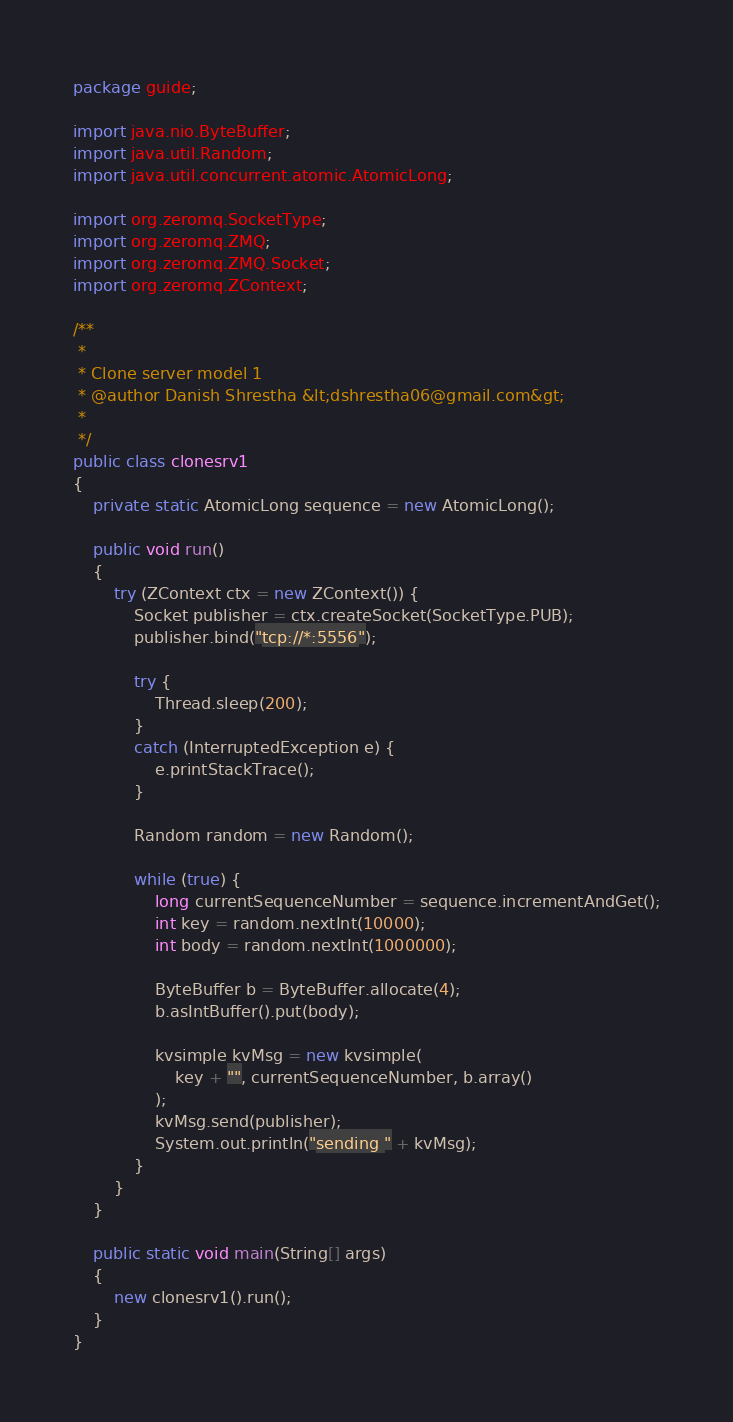Convert code to text. <code><loc_0><loc_0><loc_500><loc_500><_Java_>package guide;

import java.nio.ByteBuffer;
import java.util.Random;
import java.util.concurrent.atomic.AtomicLong;

import org.zeromq.SocketType;
import org.zeromq.ZMQ;
import org.zeromq.ZMQ.Socket;
import org.zeromq.ZContext;

/**
 * 
 * Clone server model 1
 * @author Danish Shrestha &lt;dshrestha06@gmail.com&gt;
 *
 */
public class clonesrv1
{
    private static AtomicLong sequence = new AtomicLong();

    public void run()
    {
        try (ZContext ctx = new ZContext()) {
            Socket publisher = ctx.createSocket(SocketType.PUB);
            publisher.bind("tcp://*:5556");

            try {
                Thread.sleep(200);
            }
            catch (InterruptedException e) {
                e.printStackTrace();
            }

            Random random = new Random();

            while (true) {
                long currentSequenceNumber = sequence.incrementAndGet();
                int key = random.nextInt(10000);
                int body = random.nextInt(1000000);

                ByteBuffer b = ByteBuffer.allocate(4);
                b.asIntBuffer().put(body);

                kvsimple kvMsg = new kvsimple(
                    key + "", currentSequenceNumber, b.array()
                );
                kvMsg.send(publisher);
                System.out.println("sending " + kvMsg);
            }
        }
    }

    public static void main(String[] args)
    {
        new clonesrv1().run();
    }
}
</code> 